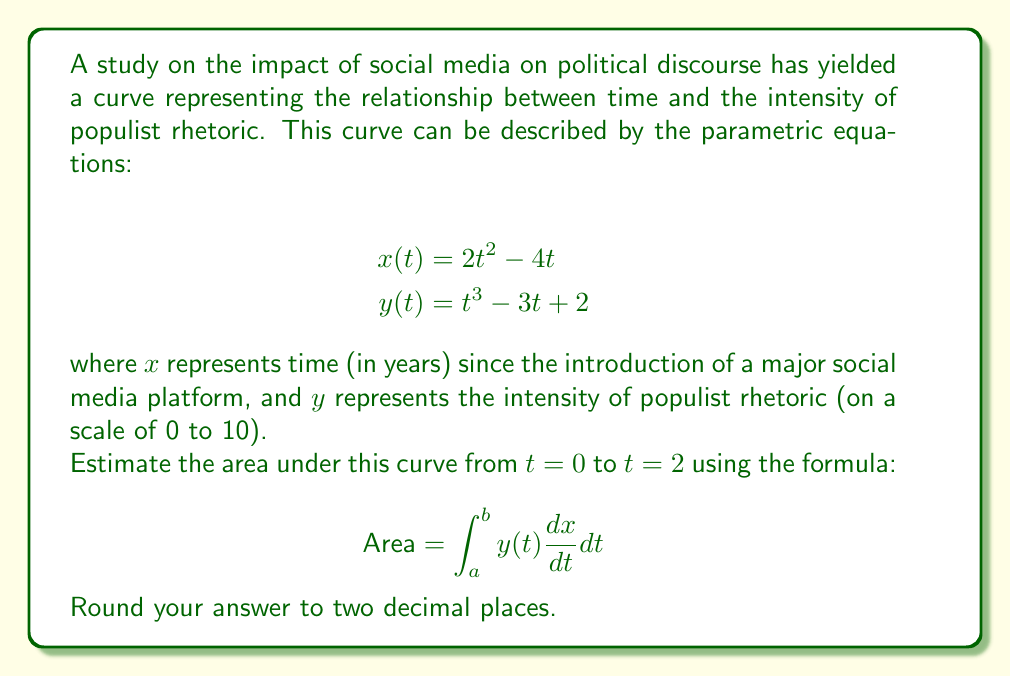Give your solution to this math problem. To solve this problem, we'll follow these steps:

1) First, we need to find $\frac{dx}{dt}$:
   $$\frac{dx}{dt} = \frac{d}{dt}(2t^2 - 4t) = 4t - 4$$

2) Now, we can set up our integral:
   $$\text{Area} = \int_{0}^{2} y(t) \frac{dx}{dt} dt$$
   $$= \int_{0}^{2} (t^3 - 3t + 2)(4t - 4) dt$$

3) Let's expand this:
   $$= \int_{0}^{2} (4t^4 - 12t^2 + 8t - 4t^3 + 12t - 8) dt$$

4) Now we can integrate:
   $$= \left[\frac{4t^5}{5} - 4t^3 + 4t^2 - t^4 + 6t^2 - 8t\right]_{0}^{2}$$

5) Evaluate at the limits:
   At $t = 2$:
   $$\frac{4(2^5)}{5} - 4(2^3) + 4(2^2) - 2^4 + 6(2^2) - 8(2) = 51.2 - 32 + 16 - 16 + 24 - 16 = 27.2$$
   
   At $t = 0$, all terms become 0.

6) Therefore, the area is:
   $$27.2 - 0 = 27.2$$

Rounding to two decimal places, we get 27.20.
Answer: 27.20 